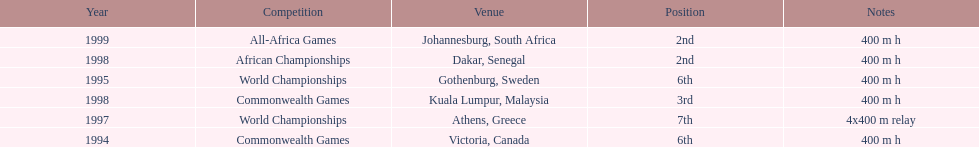What is the number of titles ken harden has one 6. 